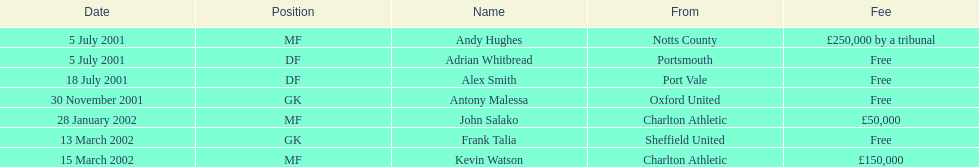After november 30, 2001, who moved or changed their location? John Salako, Frank Talia, Kevin Watson. 